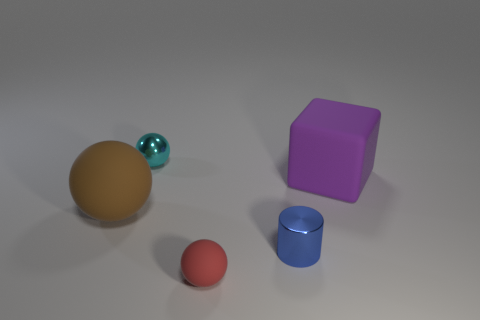Is the material of the red object the same as the cylinder?
Ensure brevity in your answer.  No. What is the tiny object on the right side of the matte sphere that is on the right side of the tiny cyan metallic thing made of?
Keep it short and to the point. Metal. How many small blue cylinders are behind the small ball on the left side of the red rubber ball in front of the large brown object?
Offer a terse response. 0. Is there any other thing of the same color as the large cube?
Provide a succinct answer. No. Do the matte thing that is in front of the blue metal object and the matte block have the same size?
Make the answer very short. No. How many cubes are behind the big object left of the purple thing?
Offer a very short reply. 1. Is there a small blue cylinder that is behind the small object that is behind the small metal thing that is in front of the big brown ball?
Make the answer very short. No. What is the material of the other big object that is the same shape as the red object?
Keep it short and to the point. Rubber. Are the red thing and the small ball that is behind the purple matte cube made of the same material?
Ensure brevity in your answer.  No. What is the shape of the small object behind the big object that is to the left of the blue metallic cylinder?
Make the answer very short. Sphere. 